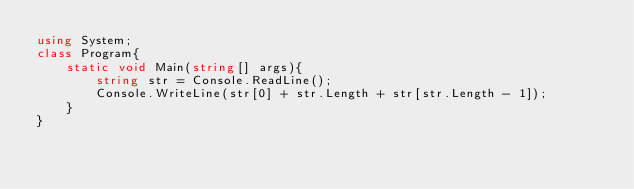Convert code to text. <code><loc_0><loc_0><loc_500><loc_500><_C#_>using System;
class Program{
    static void Main(string[] args){
        string str = Console.ReadLine();
        Console.WriteLine(str[0] + str.Length + str[str.Length - 1]);
    }
}</code> 